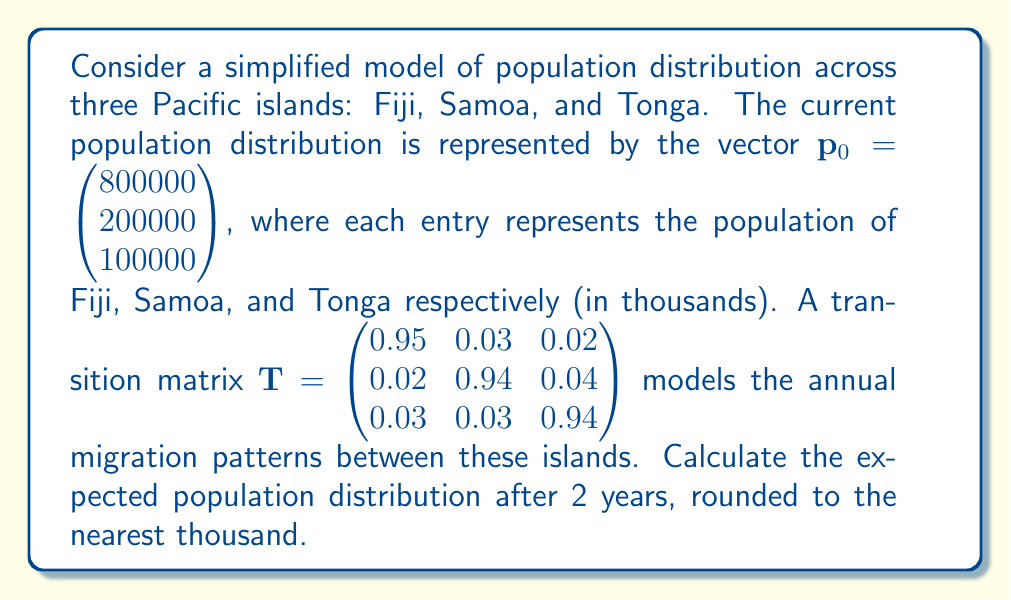What is the answer to this math problem? To solve this problem, we need to use matrix multiplication to apply the transition matrix twice to the initial population vector. Here's the step-by-step process:

1) First, let's calculate the population distribution after 1 year:
   $\mathbf{p}_1 = \mathbf{T} \cdot \mathbf{p}_0$

   $$\begin{pmatrix} 
   0.95 & 0.03 & 0.02 \\
   0.02 & 0.94 & 0.04 \\
   0.03 & 0.03 & 0.94
   \end{pmatrix} \cdot 
   \begin{pmatrix}
   800000 \\
   200000 \\
   100000
   \end{pmatrix}$$

   $= \begin{pmatrix}
   (0.95 \cdot 800000) + (0.03 \cdot 200000) + (0.02 \cdot 100000) \\
   (0.02 \cdot 800000) + (0.94 \cdot 200000) + (0.04 \cdot 100000) \\
   (0.03 \cdot 800000) + (0.03 \cdot 200000) + (0.94 \cdot 100000)
   \end{pmatrix}$

   $= \begin{pmatrix}
   770000 \\
   204000 \\
   126000
   \end{pmatrix}$

2) Now, we apply the transition matrix again to get the population after 2 years:
   $\mathbf{p}_2 = \mathbf{T} \cdot \mathbf{p}_1$

   $$\begin{pmatrix}
   0.95 & 0.03 & 0.02 \\
   0.02 & 0.94 & 0.04 \\
   0.03 & 0.03 & 0.94
   \end{pmatrix} \cdot
   \begin{pmatrix}
   770000 \\
   204000 \\
   126000
   \end{pmatrix}$$

   $= \begin{pmatrix}
   (0.95 \cdot 770000) + (0.03 \cdot 204000) + (0.02 \cdot 126000) \\
   (0.02 \cdot 770000) + (0.94 \cdot 204000) + (0.04 \cdot 126000) \\
   (0.03 \cdot 770000) + (0.03 \cdot 204000) + (0.94 \cdot 126000)
   \end{pmatrix}$

   $= \begin{pmatrix}
   741730 \\
   207460 \\
   150810
   \end{pmatrix}$

3) Rounding to the nearest thousand:

   $\mathbf{p}_2 \approx \begin{pmatrix}
   742000 \\
   207000 \\
   151000
   \end{pmatrix}$
Answer: $\begin{pmatrix} 742000 \\ 207000 \\ 151000 \end{pmatrix}$ 